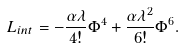Convert formula to latex. <formula><loc_0><loc_0><loc_500><loc_500>L _ { i n t } = - \frac { \alpha \lambda } { 4 ! } \Phi ^ { 4 } + \frac { \alpha \lambda ^ { 2 } } { 6 ! } \Phi ^ { 6 } .</formula> 